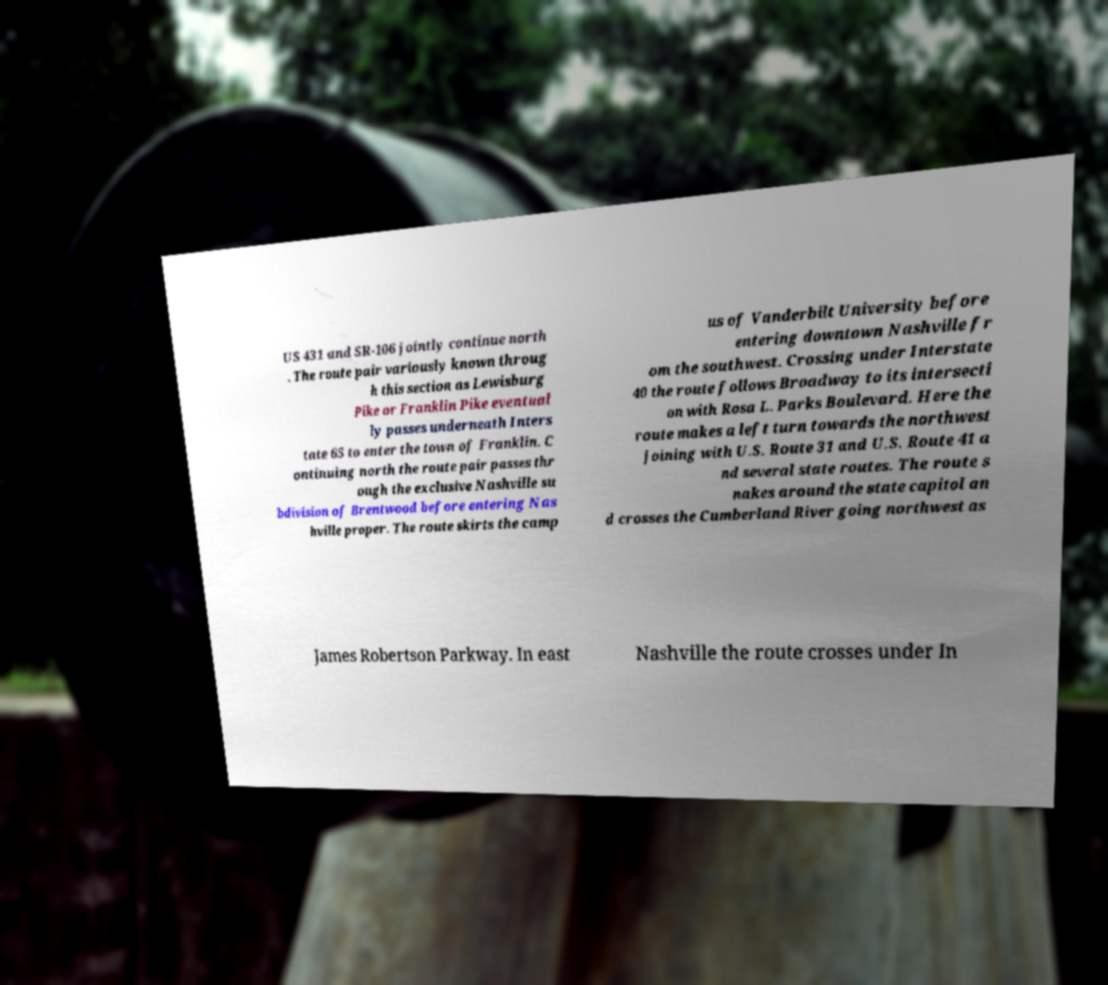Please identify and transcribe the text found in this image. US 431 and SR-106 jointly continue north . The route pair variously known throug h this section as Lewisburg Pike or Franklin Pike eventual ly passes underneath Inters tate 65 to enter the town of Franklin. C ontinuing north the route pair passes thr ough the exclusive Nashville su bdivision of Brentwood before entering Nas hville proper. The route skirts the camp us of Vanderbilt University before entering downtown Nashville fr om the southwest. Crossing under Interstate 40 the route follows Broadway to its intersecti on with Rosa L. Parks Boulevard. Here the route makes a left turn towards the northwest joining with U.S. Route 31 and U.S. Route 41 a nd several state routes. The route s nakes around the state capitol an d crosses the Cumberland River going northwest as James Robertson Parkway. In east Nashville the route crosses under In 